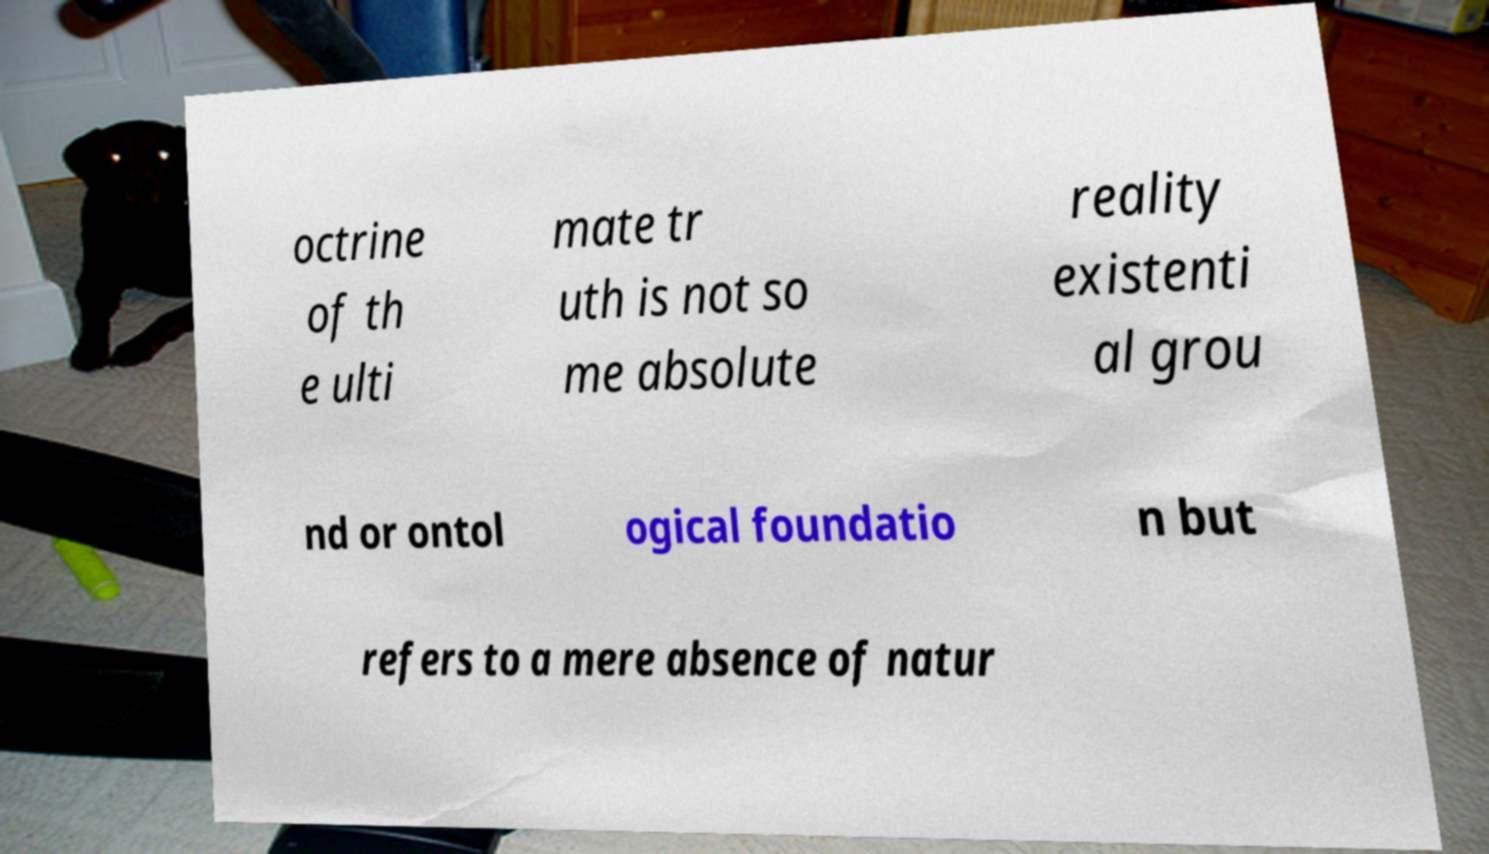Can you read and provide the text displayed in the image?This photo seems to have some interesting text. Can you extract and type it out for me? octrine of th e ulti mate tr uth is not so me absolute reality existenti al grou nd or ontol ogical foundatio n but refers to a mere absence of natur 